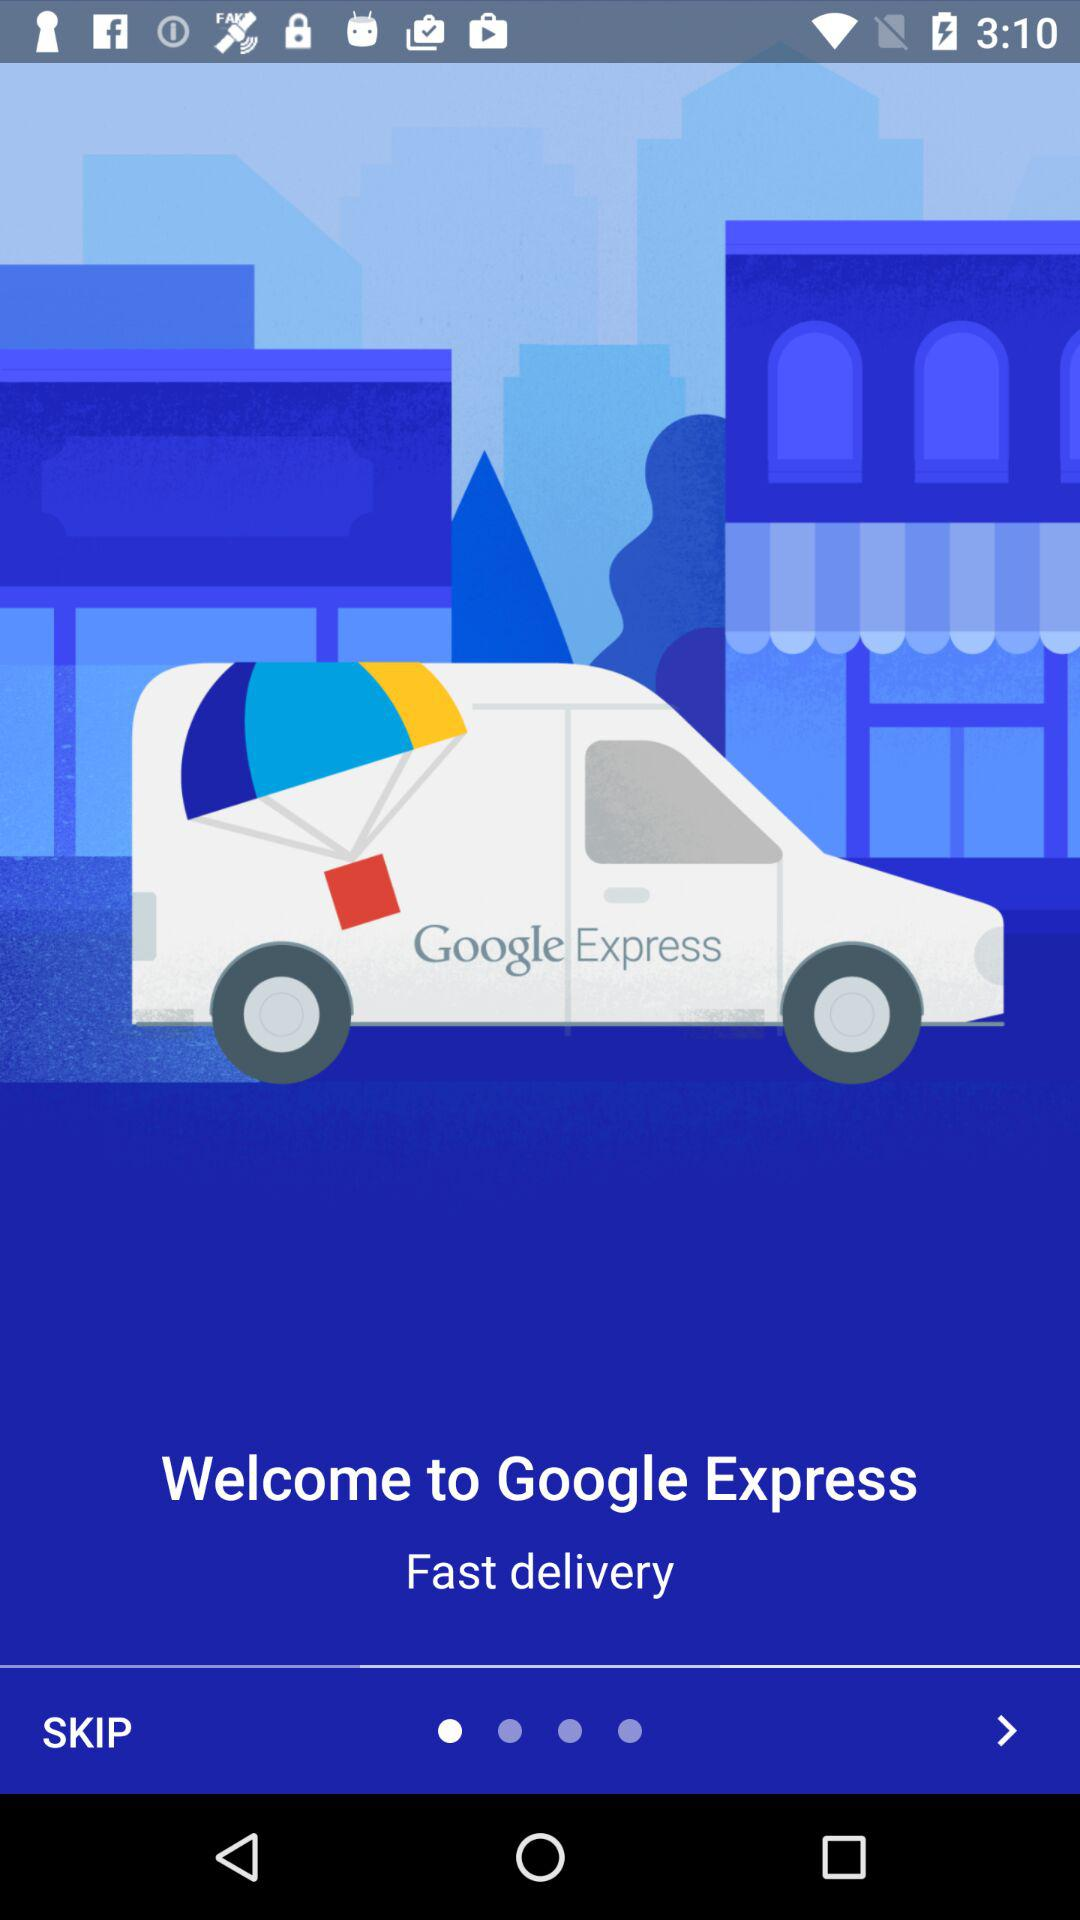How fast is the delivery?
When the provided information is insufficient, respond with <no answer>. <no answer> 